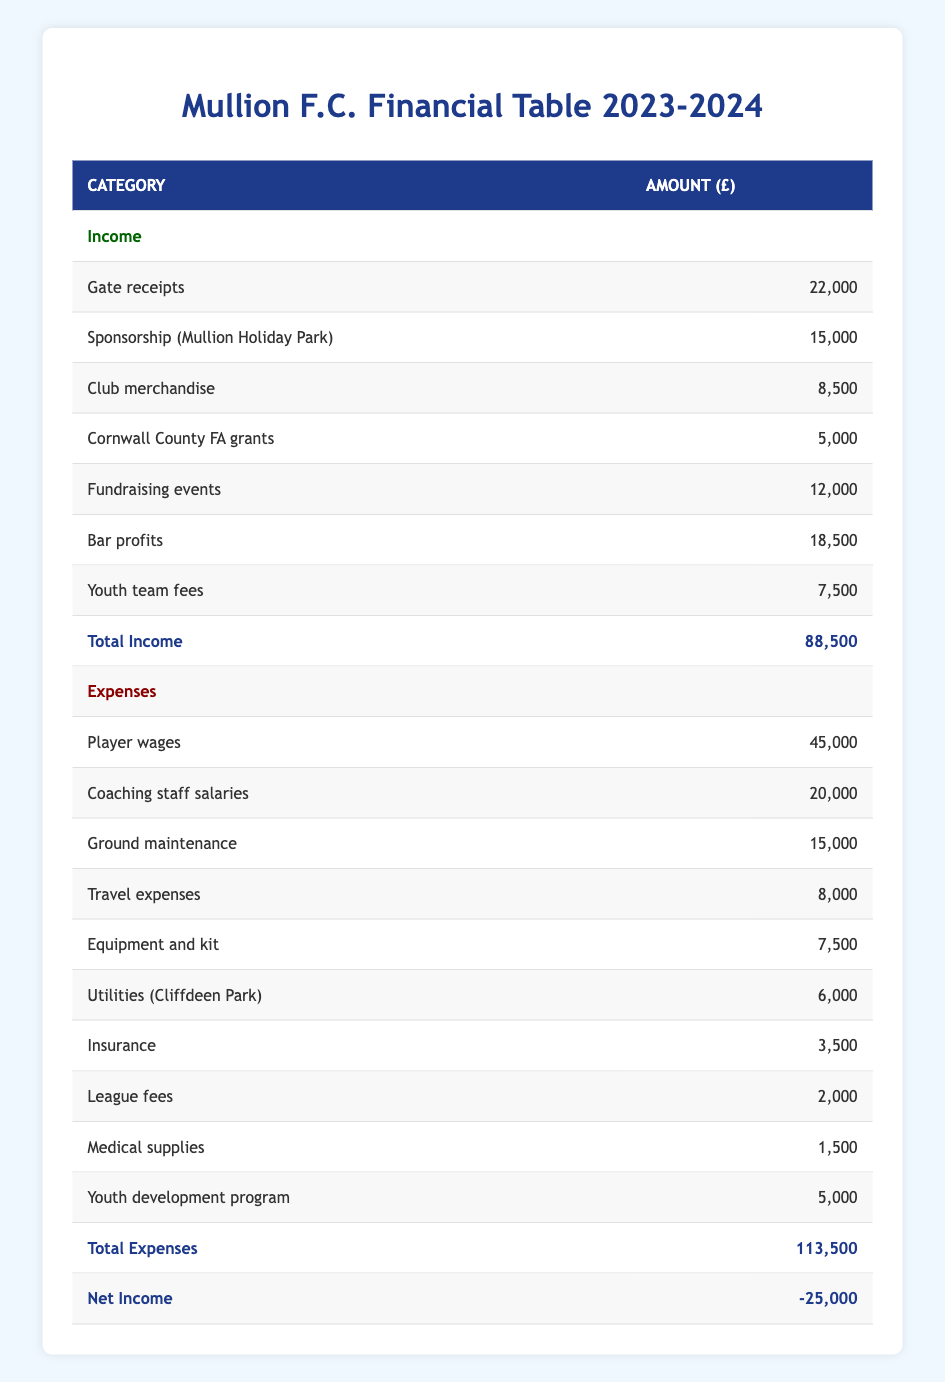What is the total income of Mullion F.C. for the 2023-2024 season? The total income can be found by looking at the bottom of the income section in the table. It states that the total income is £88,500.
Answer: 88500 What are the bar profits for this season? The bar profits are listed under the income section in the table, where it is indicated that the amount is £18,500.
Answer: 18500 Is the total budget greater than the total expenses? According to the budget breakdown, the total budget is £125,000, while the total expenses amount to £113,500. Since £125,000 is greater than £113,500, the statement is true.
Answer: Yes What is the net income for Mullion F.C. this season? The net income is provided in the final row of the table, indicating the figure to be -£25,000. This means the club is operating at a loss this season.
Answer: -25000 By how much do the total expenses exceed the total income? To find out how much total expenses exceed total income, we subtract the total income from the total expenses. That is £113,500 (expenses) - £88,500 (income) = £25,000.
Answer: 25000 Which expense category has the highest amount? Going through the expenses section, we see that "Player wages" is listed with the highest amount of £45,000.
Answer: Player wages What percentage of the total budget is spent on coaching staff salaries? To find the percentage spent on coaching staff salaries, we take the amount for coaching staff salaries (£20,000) and divide it by the total budget (£125,000), and then multiply by 100. Thus, (20,000/125,000) * 100 = 16%.
Answer: 16% How much does the club earn from youth team fees? The amount earned from youth team fees is indicated directly in the income section, which shows it to be £7,500.
Answer: 7500 Did Mullion F.C. conduct any fundraising events this season? Fundraising events are included in the income category, stating an amount of £12,000. Therefore, yes, they did conduct fundraising events.
Answer: Yes 